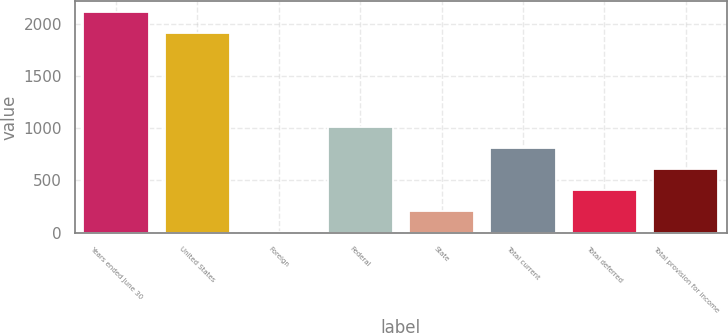Convert chart. <chart><loc_0><loc_0><loc_500><loc_500><bar_chart><fcel>Years ended June 30<fcel>United States<fcel>Foreign<fcel>Federal<fcel>State<fcel>Total current<fcel>Total deferred<fcel>Total provision for income<nl><fcel>2108.65<fcel>1908.6<fcel>8.5<fcel>1008.75<fcel>208.55<fcel>808.7<fcel>408.6<fcel>608.65<nl></chart> 